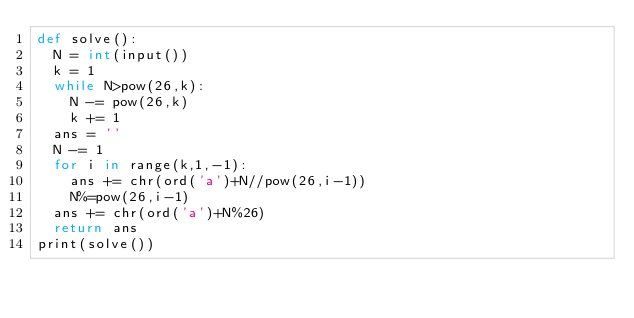<code> <loc_0><loc_0><loc_500><loc_500><_Cython_>def solve():
  N = int(input())
  k = 1
  while N>pow(26,k):
    N -= pow(26,k)
    k += 1
  ans = ''
  N -= 1
  for i in range(k,1,-1):
    ans += chr(ord('a')+N//pow(26,i-1))
    N%=pow(26,i-1)
  ans += chr(ord('a')+N%26)
  return ans
print(solve())
</code> 